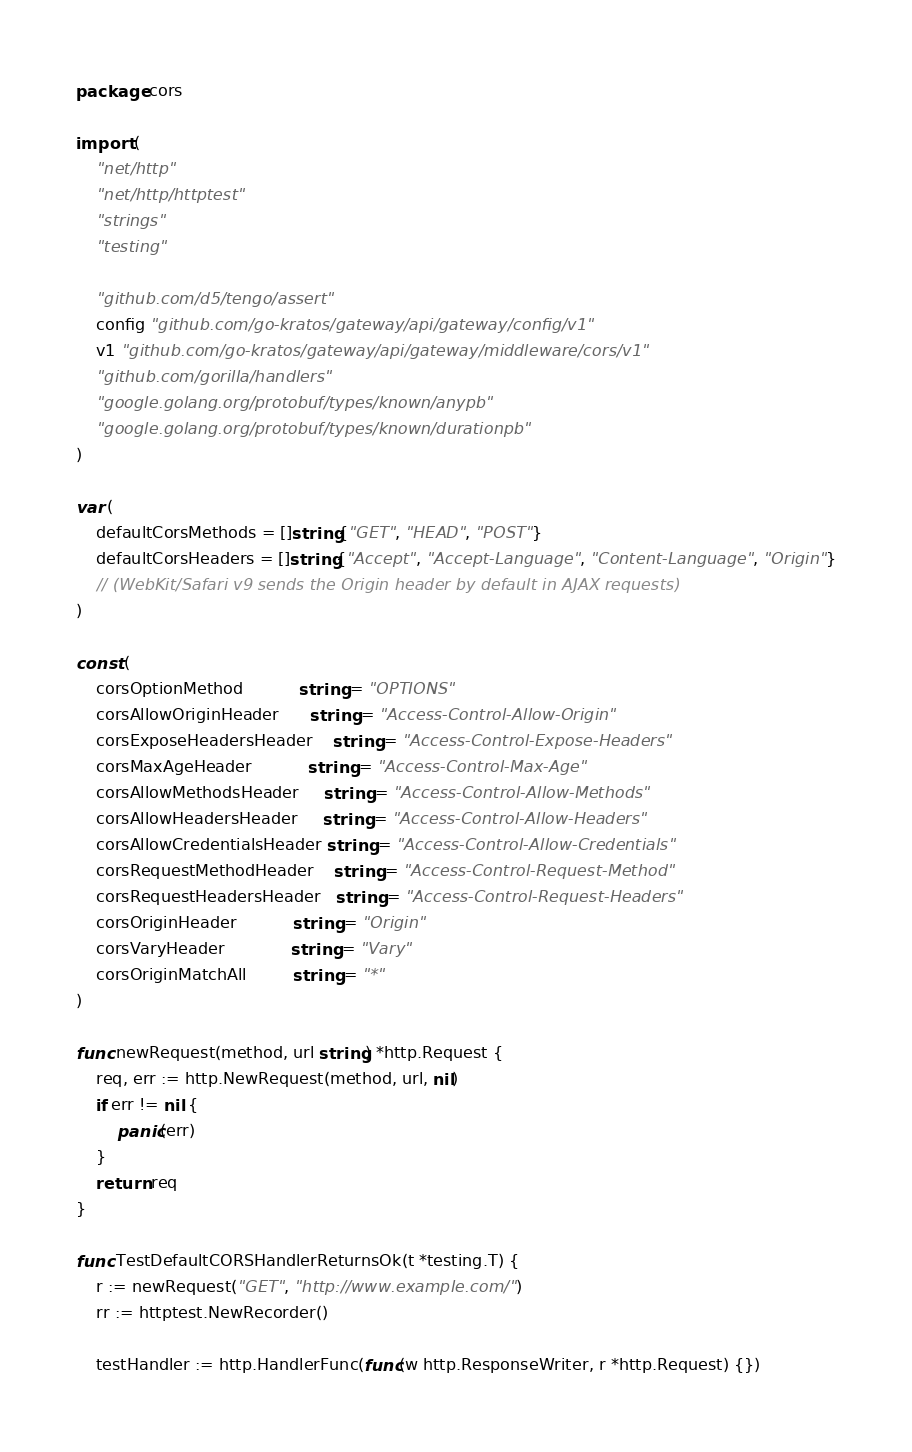Convert code to text. <code><loc_0><loc_0><loc_500><loc_500><_Go_>package cors

import (
	"net/http"
	"net/http/httptest"
	"strings"
	"testing"

	"github.com/d5/tengo/assert"
	config "github.com/go-kratos/gateway/api/gateway/config/v1"
	v1 "github.com/go-kratos/gateway/api/gateway/middleware/cors/v1"
	"github.com/gorilla/handlers"
	"google.golang.org/protobuf/types/known/anypb"
	"google.golang.org/protobuf/types/known/durationpb"
)

var (
	defaultCorsMethods = []string{"GET", "HEAD", "POST"}
	defaultCorsHeaders = []string{"Accept", "Accept-Language", "Content-Language", "Origin"}
	// (WebKit/Safari v9 sends the Origin header by default in AJAX requests)
)

const (
	corsOptionMethod           string = "OPTIONS"
	corsAllowOriginHeader      string = "Access-Control-Allow-Origin"
	corsExposeHeadersHeader    string = "Access-Control-Expose-Headers"
	corsMaxAgeHeader           string = "Access-Control-Max-Age"
	corsAllowMethodsHeader     string = "Access-Control-Allow-Methods"
	corsAllowHeadersHeader     string = "Access-Control-Allow-Headers"
	corsAllowCredentialsHeader string = "Access-Control-Allow-Credentials"
	corsRequestMethodHeader    string = "Access-Control-Request-Method"
	corsRequestHeadersHeader   string = "Access-Control-Request-Headers"
	corsOriginHeader           string = "Origin"
	corsVaryHeader             string = "Vary"
	corsOriginMatchAll         string = "*"
)

func newRequest(method, url string) *http.Request {
	req, err := http.NewRequest(method, url, nil)
	if err != nil {
		panic(err)
	}
	return req
}

func TestDefaultCORSHandlerReturnsOk(t *testing.T) {
	r := newRequest("GET", "http://www.example.com/")
	rr := httptest.NewRecorder()

	testHandler := http.HandlerFunc(func(w http.ResponseWriter, r *http.Request) {})
</code> 